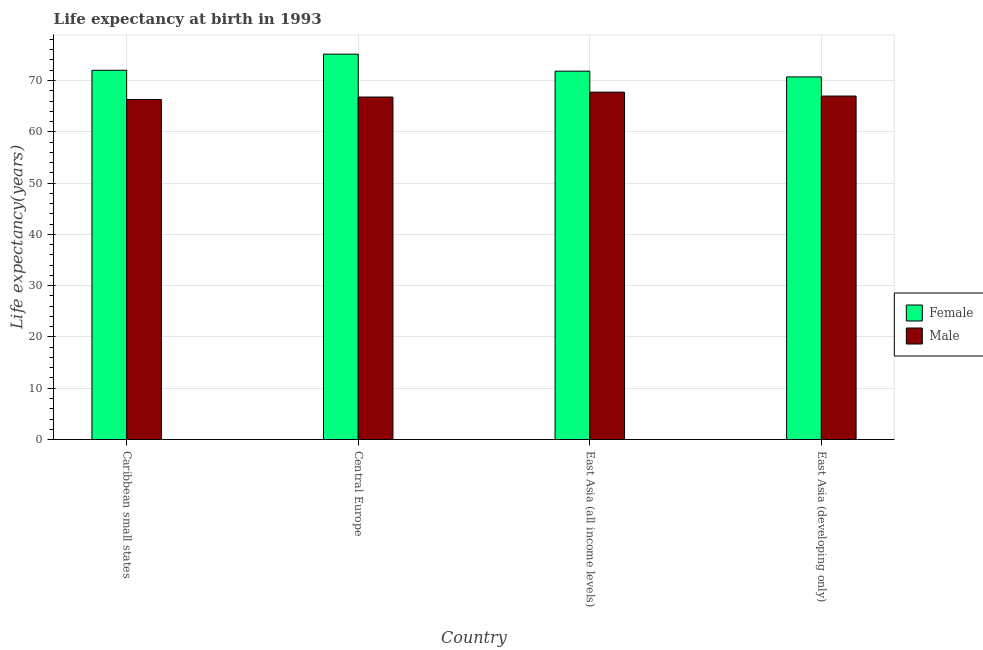How many bars are there on the 3rd tick from the left?
Your response must be concise. 2. How many bars are there on the 3rd tick from the right?
Offer a terse response. 2. What is the label of the 1st group of bars from the left?
Your answer should be very brief. Caribbean small states. What is the life expectancy(female) in Caribbean small states?
Your response must be concise. 71.99. Across all countries, what is the maximum life expectancy(male)?
Ensure brevity in your answer.  67.73. Across all countries, what is the minimum life expectancy(male)?
Your answer should be very brief. 66.3. In which country was the life expectancy(male) maximum?
Your answer should be compact. East Asia (all income levels). In which country was the life expectancy(male) minimum?
Your response must be concise. Caribbean small states. What is the total life expectancy(male) in the graph?
Offer a terse response. 267.77. What is the difference between the life expectancy(male) in East Asia (all income levels) and that in East Asia (developing only)?
Your answer should be very brief. 0.77. What is the difference between the life expectancy(female) in East Asia (developing only) and the life expectancy(male) in Central Europe?
Give a very brief answer. 3.93. What is the average life expectancy(male) per country?
Offer a very short reply. 66.94. What is the difference between the life expectancy(female) and life expectancy(male) in Caribbean small states?
Give a very brief answer. 5.7. What is the ratio of the life expectancy(male) in Caribbean small states to that in Central Europe?
Offer a terse response. 0.99. Is the life expectancy(female) in Caribbean small states less than that in Central Europe?
Provide a succinct answer. Yes. Is the difference between the life expectancy(female) in Central Europe and East Asia (all income levels) greater than the difference between the life expectancy(male) in Central Europe and East Asia (all income levels)?
Your response must be concise. Yes. What is the difference between the highest and the second highest life expectancy(male)?
Provide a succinct answer. 0.77. What is the difference between the highest and the lowest life expectancy(male)?
Your response must be concise. 1.44. What does the 1st bar from the left in East Asia (all income levels) represents?
Provide a short and direct response. Female. What does the 1st bar from the right in East Asia (developing only) represents?
Ensure brevity in your answer.  Male. How many countries are there in the graph?
Offer a very short reply. 4. What is the difference between two consecutive major ticks on the Y-axis?
Keep it short and to the point. 10. Does the graph contain any zero values?
Ensure brevity in your answer.  No. Does the graph contain grids?
Make the answer very short. Yes. Where does the legend appear in the graph?
Your answer should be very brief. Center right. How many legend labels are there?
Offer a terse response. 2. How are the legend labels stacked?
Your response must be concise. Vertical. What is the title of the graph?
Your response must be concise. Life expectancy at birth in 1993. What is the label or title of the X-axis?
Keep it short and to the point. Country. What is the label or title of the Y-axis?
Offer a terse response. Life expectancy(years). What is the Life expectancy(years) of Female in Caribbean small states?
Keep it short and to the point. 71.99. What is the Life expectancy(years) in Male in Caribbean small states?
Your answer should be compact. 66.3. What is the Life expectancy(years) in Female in Central Europe?
Your response must be concise. 75.14. What is the Life expectancy(years) in Male in Central Europe?
Offer a very short reply. 66.77. What is the Life expectancy(years) in Female in East Asia (all income levels)?
Provide a succinct answer. 71.82. What is the Life expectancy(years) in Male in East Asia (all income levels)?
Your answer should be compact. 67.73. What is the Life expectancy(years) in Female in East Asia (developing only)?
Your response must be concise. 70.7. What is the Life expectancy(years) of Male in East Asia (developing only)?
Provide a succinct answer. 66.97. Across all countries, what is the maximum Life expectancy(years) of Female?
Offer a terse response. 75.14. Across all countries, what is the maximum Life expectancy(years) of Male?
Offer a terse response. 67.73. Across all countries, what is the minimum Life expectancy(years) in Female?
Offer a very short reply. 70.7. Across all countries, what is the minimum Life expectancy(years) in Male?
Offer a very short reply. 66.3. What is the total Life expectancy(years) in Female in the graph?
Provide a short and direct response. 289.65. What is the total Life expectancy(years) of Male in the graph?
Give a very brief answer. 267.77. What is the difference between the Life expectancy(years) in Female in Caribbean small states and that in Central Europe?
Give a very brief answer. -3.15. What is the difference between the Life expectancy(years) in Male in Caribbean small states and that in Central Europe?
Provide a short and direct response. -0.48. What is the difference between the Life expectancy(years) in Female in Caribbean small states and that in East Asia (all income levels)?
Your answer should be compact. 0.17. What is the difference between the Life expectancy(years) in Male in Caribbean small states and that in East Asia (all income levels)?
Your response must be concise. -1.44. What is the difference between the Life expectancy(years) of Female in Caribbean small states and that in East Asia (developing only)?
Provide a short and direct response. 1.29. What is the difference between the Life expectancy(years) of Male in Caribbean small states and that in East Asia (developing only)?
Keep it short and to the point. -0.67. What is the difference between the Life expectancy(years) of Female in Central Europe and that in East Asia (all income levels)?
Your answer should be compact. 3.32. What is the difference between the Life expectancy(years) in Male in Central Europe and that in East Asia (all income levels)?
Your answer should be compact. -0.96. What is the difference between the Life expectancy(years) in Female in Central Europe and that in East Asia (developing only)?
Keep it short and to the point. 4.44. What is the difference between the Life expectancy(years) of Male in Central Europe and that in East Asia (developing only)?
Your answer should be very brief. -0.19. What is the difference between the Life expectancy(years) in Female in East Asia (all income levels) and that in East Asia (developing only)?
Your answer should be very brief. 1.12. What is the difference between the Life expectancy(years) of Male in East Asia (all income levels) and that in East Asia (developing only)?
Give a very brief answer. 0.77. What is the difference between the Life expectancy(years) in Female in Caribbean small states and the Life expectancy(years) in Male in Central Europe?
Your answer should be compact. 5.22. What is the difference between the Life expectancy(years) of Female in Caribbean small states and the Life expectancy(years) of Male in East Asia (all income levels)?
Keep it short and to the point. 4.26. What is the difference between the Life expectancy(years) in Female in Caribbean small states and the Life expectancy(years) in Male in East Asia (developing only)?
Provide a succinct answer. 5.03. What is the difference between the Life expectancy(years) of Female in Central Europe and the Life expectancy(years) of Male in East Asia (all income levels)?
Make the answer very short. 7.41. What is the difference between the Life expectancy(years) in Female in Central Europe and the Life expectancy(years) in Male in East Asia (developing only)?
Keep it short and to the point. 8.17. What is the difference between the Life expectancy(years) in Female in East Asia (all income levels) and the Life expectancy(years) in Male in East Asia (developing only)?
Ensure brevity in your answer.  4.86. What is the average Life expectancy(years) in Female per country?
Your response must be concise. 72.41. What is the average Life expectancy(years) in Male per country?
Your response must be concise. 66.94. What is the difference between the Life expectancy(years) of Female and Life expectancy(years) of Male in Caribbean small states?
Your answer should be very brief. 5.7. What is the difference between the Life expectancy(years) of Female and Life expectancy(years) of Male in Central Europe?
Make the answer very short. 8.36. What is the difference between the Life expectancy(years) of Female and Life expectancy(years) of Male in East Asia (all income levels)?
Your response must be concise. 4.09. What is the difference between the Life expectancy(years) in Female and Life expectancy(years) in Male in East Asia (developing only)?
Ensure brevity in your answer.  3.73. What is the ratio of the Life expectancy(years) of Female in Caribbean small states to that in Central Europe?
Provide a short and direct response. 0.96. What is the ratio of the Life expectancy(years) of Male in Caribbean small states to that in Central Europe?
Give a very brief answer. 0.99. What is the ratio of the Life expectancy(years) of Male in Caribbean small states to that in East Asia (all income levels)?
Your answer should be very brief. 0.98. What is the ratio of the Life expectancy(years) of Female in Caribbean small states to that in East Asia (developing only)?
Your answer should be very brief. 1.02. What is the ratio of the Life expectancy(years) in Male in Caribbean small states to that in East Asia (developing only)?
Your answer should be compact. 0.99. What is the ratio of the Life expectancy(years) of Female in Central Europe to that in East Asia (all income levels)?
Offer a terse response. 1.05. What is the ratio of the Life expectancy(years) in Male in Central Europe to that in East Asia (all income levels)?
Offer a terse response. 0.99. What is the ratio of the Life expectancy(years) in Female in Central Europe to that in East Asia (developing only)?
Provide a succinct answer. 1.06. What is the ratio of the Life expectancy(years) of Male in Central Europe to that in East Asia (developing only)?
Keep it short and to the point. 1. What is the ratio of the Life expectancy(years) in Female in East Asia (all income levels) to that in East Asia (developing only)?
Your answer should be very brief. 1.02. What is the ratio of the Life expectancy(years) in Male in East Asia (all income levels) to that in East Asia (developing only)?
Provide a short and direct response. 1.01. What is the difference between the highest and the second highest Life expectancy(years) in Female?
Give a very brief answer. 3.15. What is the difference between the highest and the second highest Life expectancy(years) in Male?
Give a very brief answer. 0.77. What is the difference between the highest and the lowest Life expectancy(years) of Female?
Make the answer very short. 4.44. What is the difference between the highest and the lowest Life expectancy(years) of Male?
Ensure brevity in your answer.  1.44. 